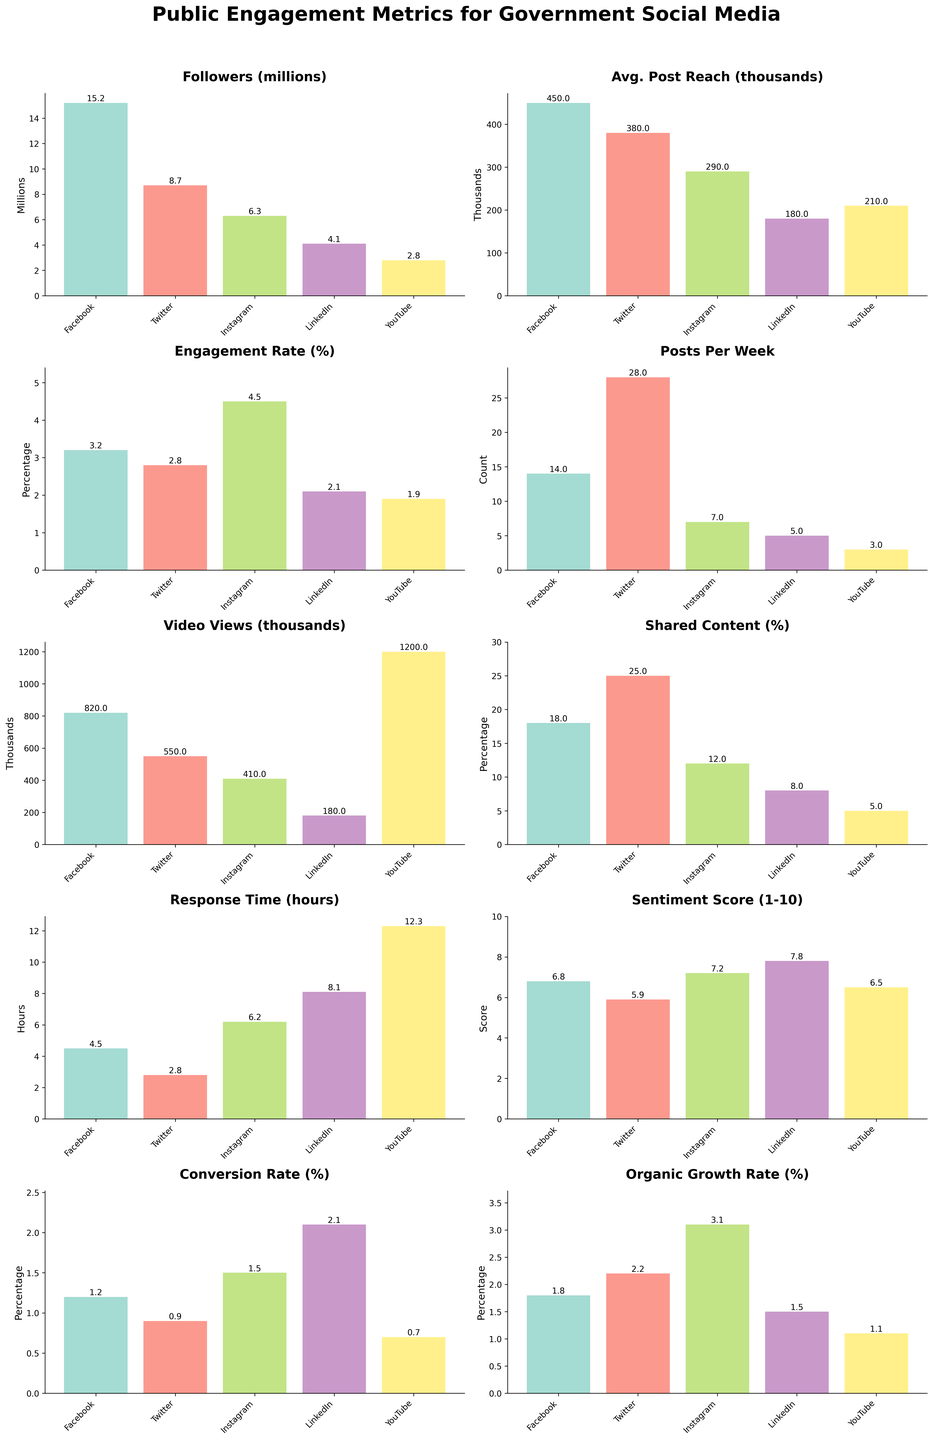what is the average engagement rate across all platforms? The engagement rates for all platforms are Facebook: 3.2%, Twitter: 2.8%, Instagram: 4.5%, LinkedIn: 2.1%, and YouTube: 1.9%. Adding these together gives 3.2 + 2.8 + 4.5 + 2.1 + 1.9 = 14.5. Dividing by the number of platforms (5) gives 14.5 / 5 = 2.9%
Answer: 2.9% Which platform has the highest number of followers? Looking at the values for followers in millions for all platforms, Facebook has 15.2 million, Twitter has 8.7 million, Instagram has 6.3 million, LinkedIn has 4.1 million, and YouTube has 2.8 million. Facebook has the highest number of followers.
Answer: Facebook What is the difference between response times for LinkedIn and Facebook? The response time for LinkedIn is 8.1 hours, and for Facebook, it is 4.5 hours. The difference is 8.1 - 4.5 = 3.6 hours.
Answer: 3.6 hours Which platform has the highest video views? By examining the video views in thousands, YouTube has the highest video views at 1200 thousand.
Answer: YouTube What is the sum of average post reaches for Facebook and Twitter? The average post reach for Facebook is 450 thousand and for Twitter, it is 380 thousand. Adding these together gives 450 + 380 = 830 thousand.
Answer: 830 thousand Which platform has the lowest conversion rate? The conversion rates across the platforms are Facebook: 1.2%, Twitter: 0.9%, Instagram: 1.5%, LinkedIn: 2.1%, and YouTube: 0.7%. YouTube has the lowest conversion rate at 0.7%.
Answer: YouTube What is the median sentiment score among all platforms? The sentiment scores are Facebook: 6.8, Twitter: 5.9, Instagram: 7.2, LinkedIn: 7.8, and YouTube: 6.5. Arranging them in ascending order gives 5.9, 6.5, 6.8, 7.2, 7.8. The median score is the middle value, 6.8.
Answer: 6.8 Which platform has a higher shared content percentage, LinkedIn or Instagram? The shared content percentage for LinkedIn and Instagram are 8% and 12% respectively. Instagram has a higher shared content percentage.
Answer: Instagram What is the average number of posts per week across all platforms? The number of posts per week are Facebook: 14, Twitter: 28, Instagram: 7, LinkedIn: 5, YouTube: 3. Adding these together gives 14 + 28 + 7 + 5 + 3 = 57. Dividing by the number of platforms (5) gives 57 / 5 = 11.4.
Answer: 11.4 Between Instagram and Twitter, which has a higher organic growth rate? Instagram's organic growth rate is 3.1% and Twitter's is 2.2%. Instagram has a higher organic growth rate.
Answer: Instagram 